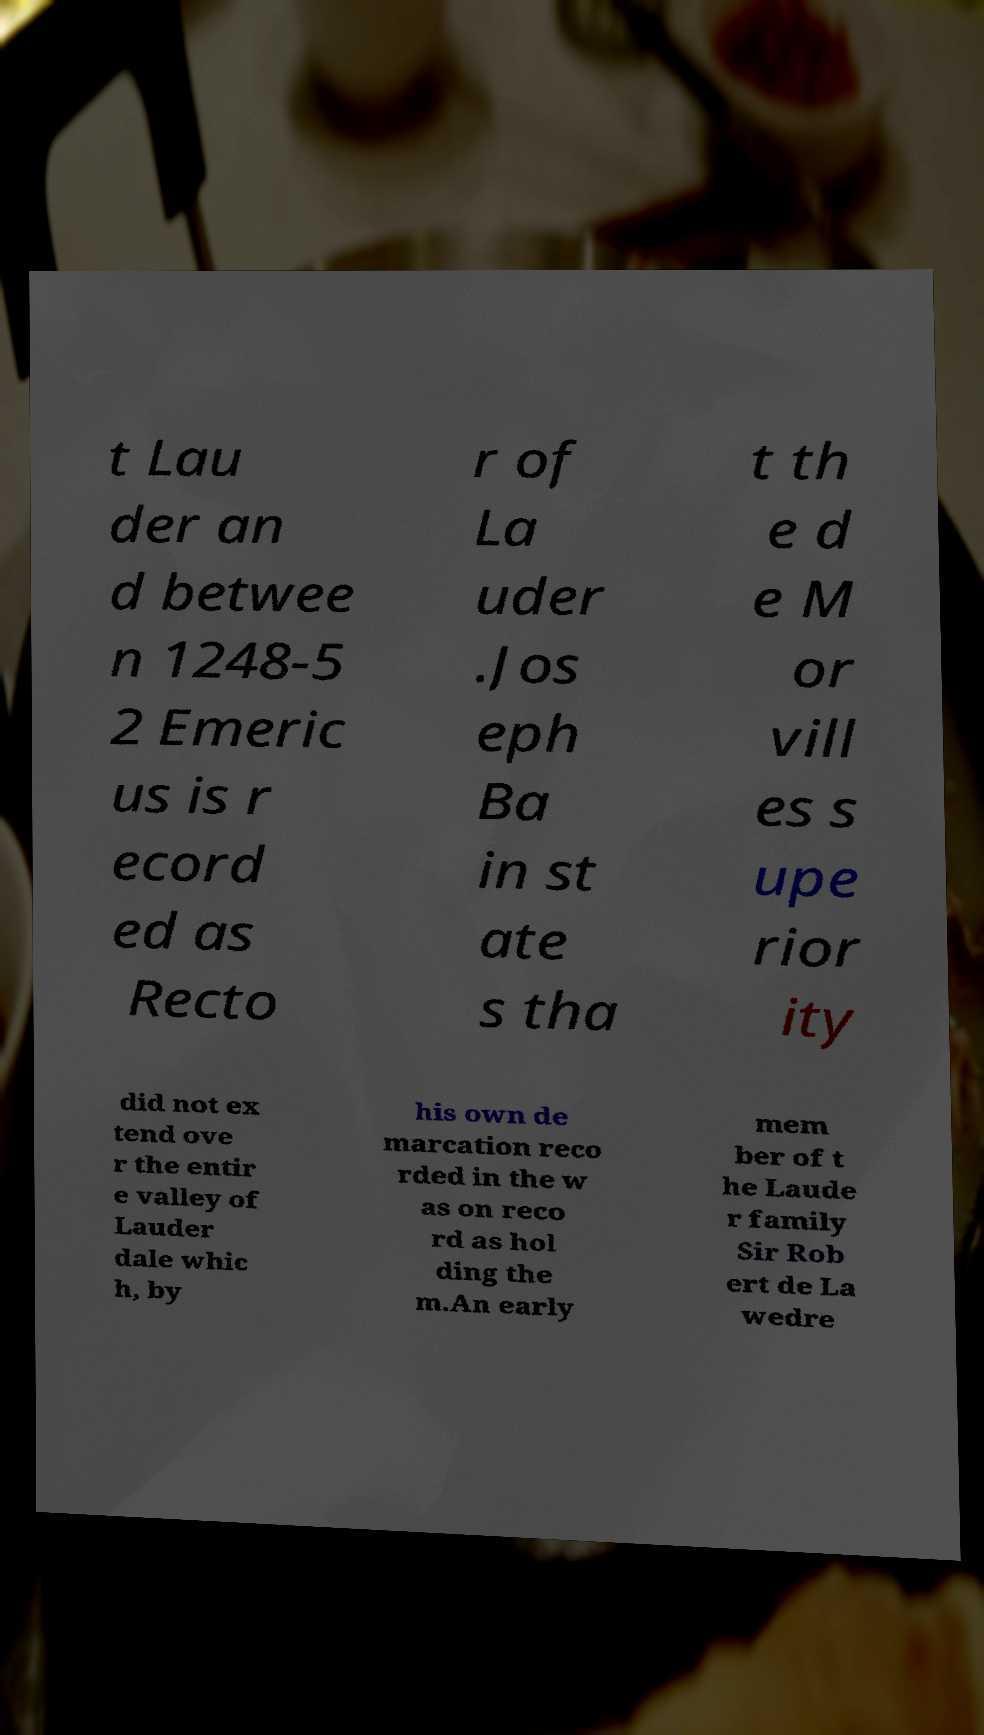Could you extract and type out the text from this image? t Lau der an d betwee n 1248-5 2 Emeric us is r ecord ed as Recto r of La uder .Jos eph Ba in st ate s tha t th e d e M or vill es s upe rior ity did not ex tend ove r the entir e valley of Lauder dale whic h, by his own de marcation reco rded in the w as on reco rd as hol ding the m.An early mem ber of t he Laude r family Sir Rob ert de La wedre 